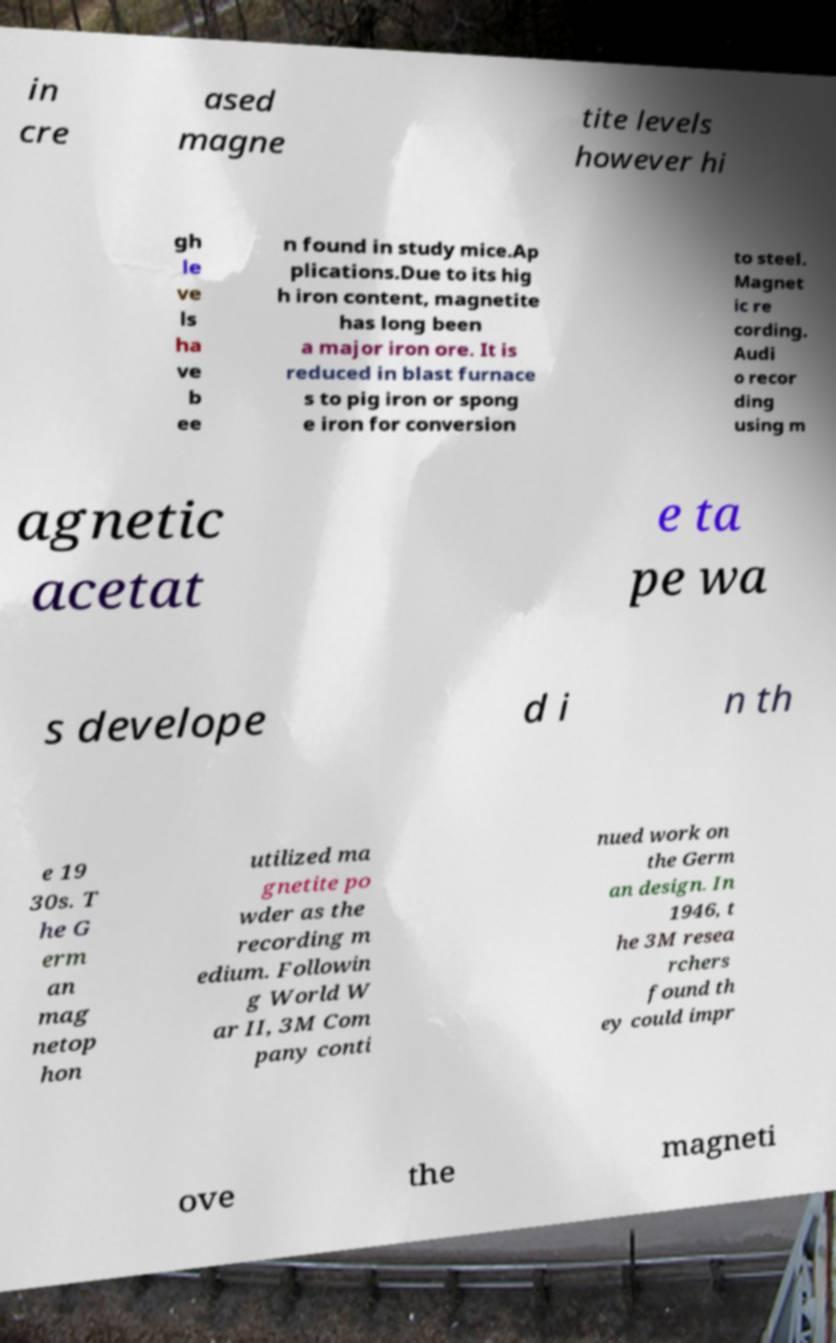I need the written content from this picture converted into text. Can you do that? in cre ased magne tite levels however hi gh le ve ls ha ve b ee n found in study mice.Ap plications.Due to its hig h iron content, magnetite has long been a major iron ore. It is reduced in blast furnace s to pig iron or spong e iron for conversion to steel. Magnet ic re cording. Audi o recor ding using m agnetic acetat e ta pe wa s develope d i n th e 19 30s. T he G erm an mag netop hon utilized ma gnetite po wder as the recording m edium. Followin g World W ar II, 3M Com pany conti nued work on the Germ an design. In 1946, t he 3M resea rchers found th ey could impr ove the magneti 